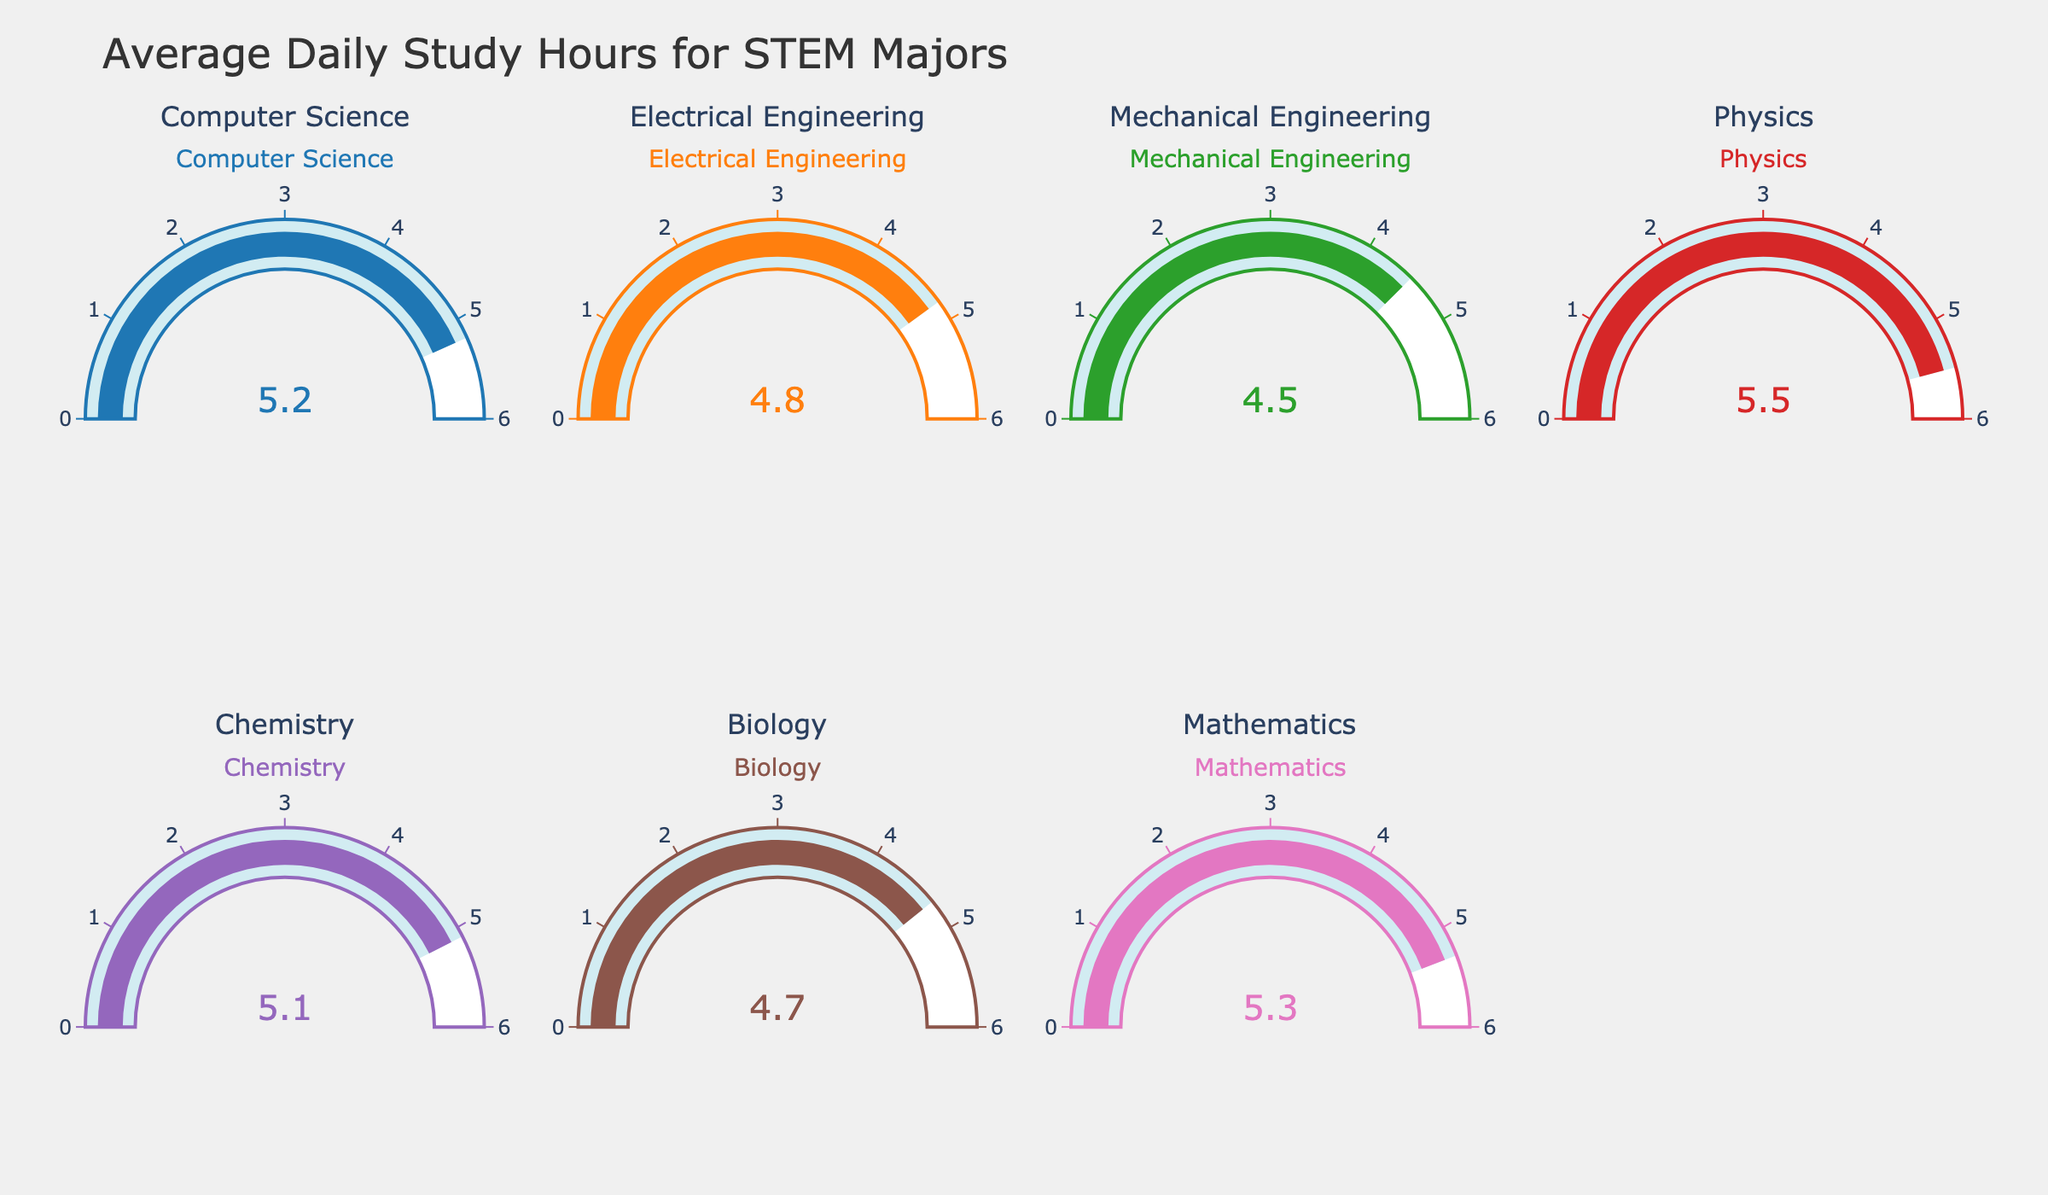What's the title of the figure? The title of the figure is displayed at the top of the plot.
Answer: Average Daily Study Hours for STEM Majors How many majors are represented in the figure? Count the number of gauge charts, each representing a different major. There are 7 gauges.
Answer: 7 Which major has the highest average daily study hours? Look at the gauge with the highest numerical value. Physics has the highest value at 5.5 hours.
Answer: Physics What is the average daily study hours for Biology majors? Refer to the specific gauge for Biology. The value is 4.7 hours.
Answer: 4.7 hours What is the difference in average daily study hours between Physics and Chemistry majors? Subtract the value of Chemistry from the value of Physics: 5.5 - 5.1 = 0.4 hours.
Answer: 0.4 hours Which major has the lowest average daily study hours? Look at the gauge with the lowest numerical value. Mechanical Engineering has the lowest value at 4.5 hours.
Answer: Mechanical Engineering Are there any majors with exactly 5.0 hours of study time? Check each gauge for the value 5.0. None of the gauges display exactly 5.0 hours.
Answer: No What is the difference between the highest and lowest average study hours? Subtract the lowest value (Mechanical Engineering, 4.5) from the highest value (Physics, 5.5): 5.5 - 4.5 = 1.0 hour.
Answer: 1.0 hour How does the average study time for Mathematics compare to Computer Science? Compare the values: Mathematics has 5.3 and Computer Science has 5.2. Mathematics is higher by 0.1 hours.
Answer: Mathematics is higher by 0.1 hours 